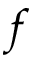Convert formula to latex. <formula><loc_0><loc_0><loc_500><loc_500>f</formula> 